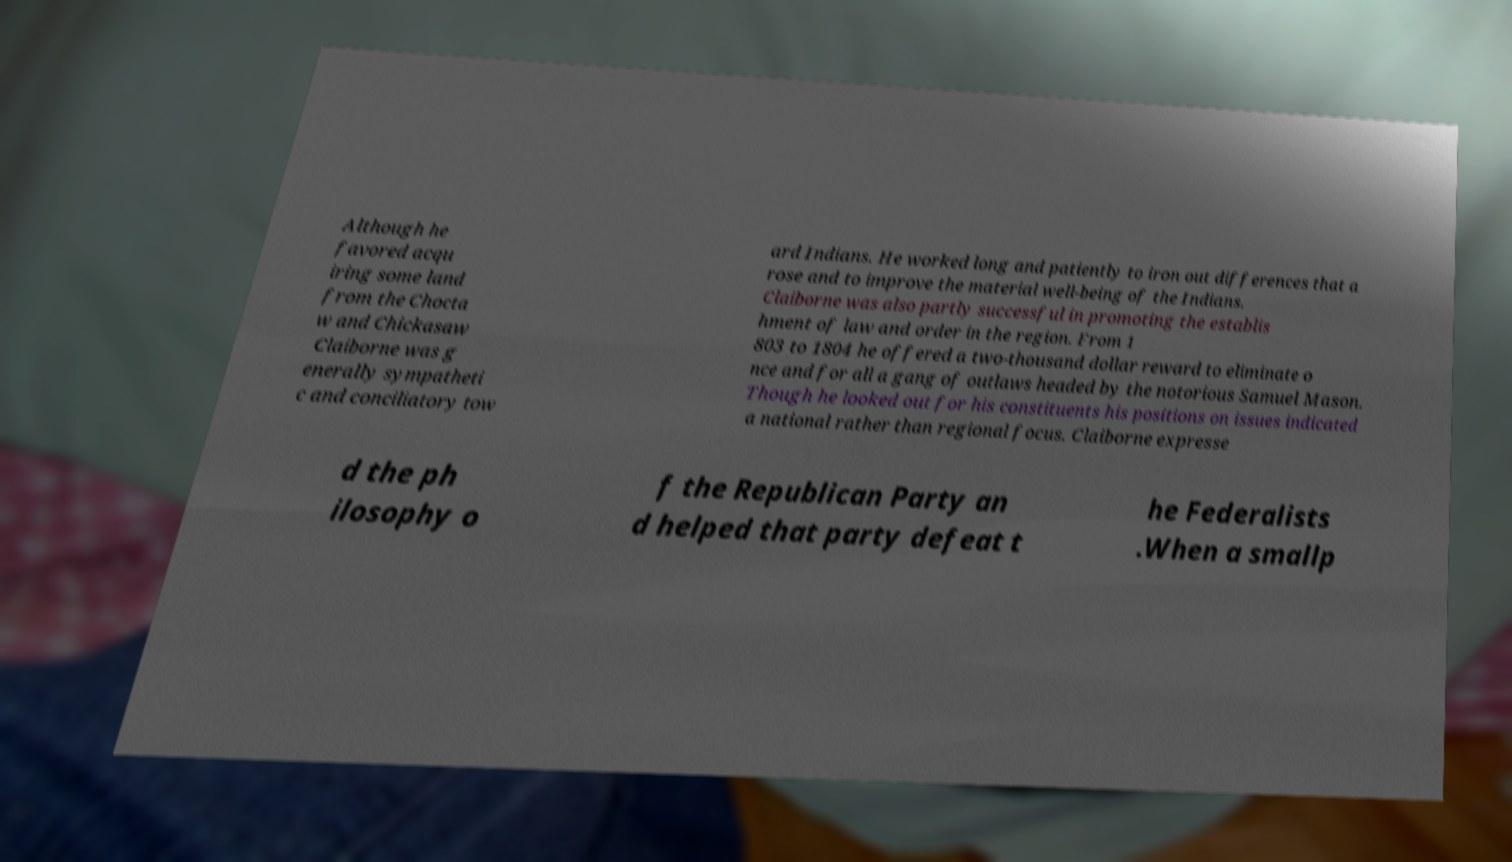Can you accurately transcribe the text from the provided image for me? Although he favored acqu iring some land from the Chocta w and Chickasaw Claiborne was g enerally sympatheti c and conciliatory tow ard Indians. He worked long and patiently to iron out differences that a rose and to improve the material well-being of the Indians. Claiborne was also partly successful in promoting the establis hment of law and order in the region. From 1 803 to 1804 he offered a two-thousand dollar reward to eliminate o nce and for all a gang of outlaws headed by the notorious Samuel Mason. Though he looked out for his constituents his positions on issues indicated a national rather than regional focus. Claiborne expresse d the ph ilosophy o f the Republican Party an d helped that party defeat t he Federalists .When a smallp 